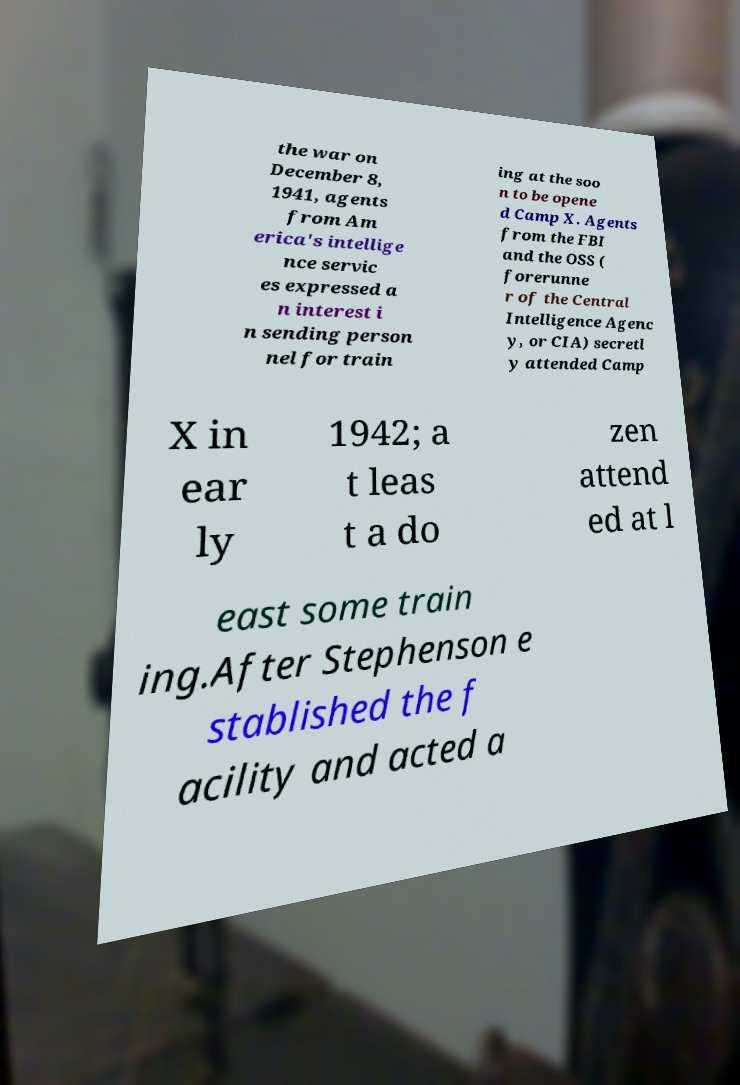Please identify and transcribe the text found in this image. the war on December 8, 1941, agents from Am erica's intellige nce servic es expressed a n interest i n sending person nel for train ing at the soo n to be opene d Camp X. Agents from the FBI and the OSS ( forerunne r of the Central Intelligence Agenc y, or CIA) secretl y attended Camp X in ear ly 1942; a t leas t a do zen attend ed at l east some train ing.After Stephenson e stablished the f acility and acted a 